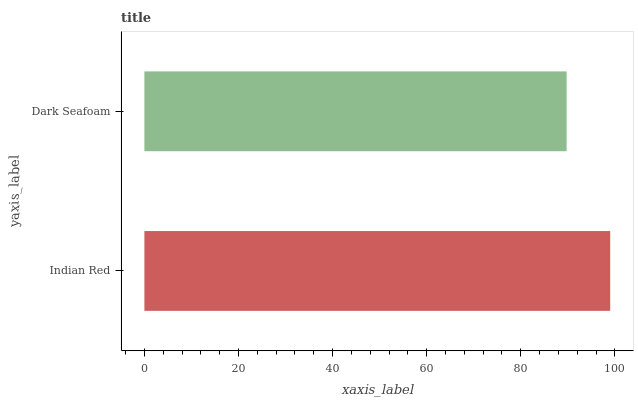Is Dark Seafoam the minimum?
Answer yes or no. Yes. Is Indian Red the maximum?
Answer yes or no. Yes. Is Dark Seafoam the maximum?
Answer yes or no. No. Is Indian Red greater than Dark Seafoam?
Answer yes or no. Yes. Is Dark Seafoam less than Indian Red?
Answer yes or no. Yes. Is Dark Seafoam greater than Indian Red?
Answer yes or no. No. Is Indian Red less than Dark Seafoam?
Answer yes or no. No. Is Indian Red the high median?
Answer yes or no. Yes. Is Dark Seafoam the low median?
Answer yes or no. Yes. Is Dark Seafoam the high median?
Answer yes or no. No. Is Indian Red the low median?
Answer yes or no. No. 